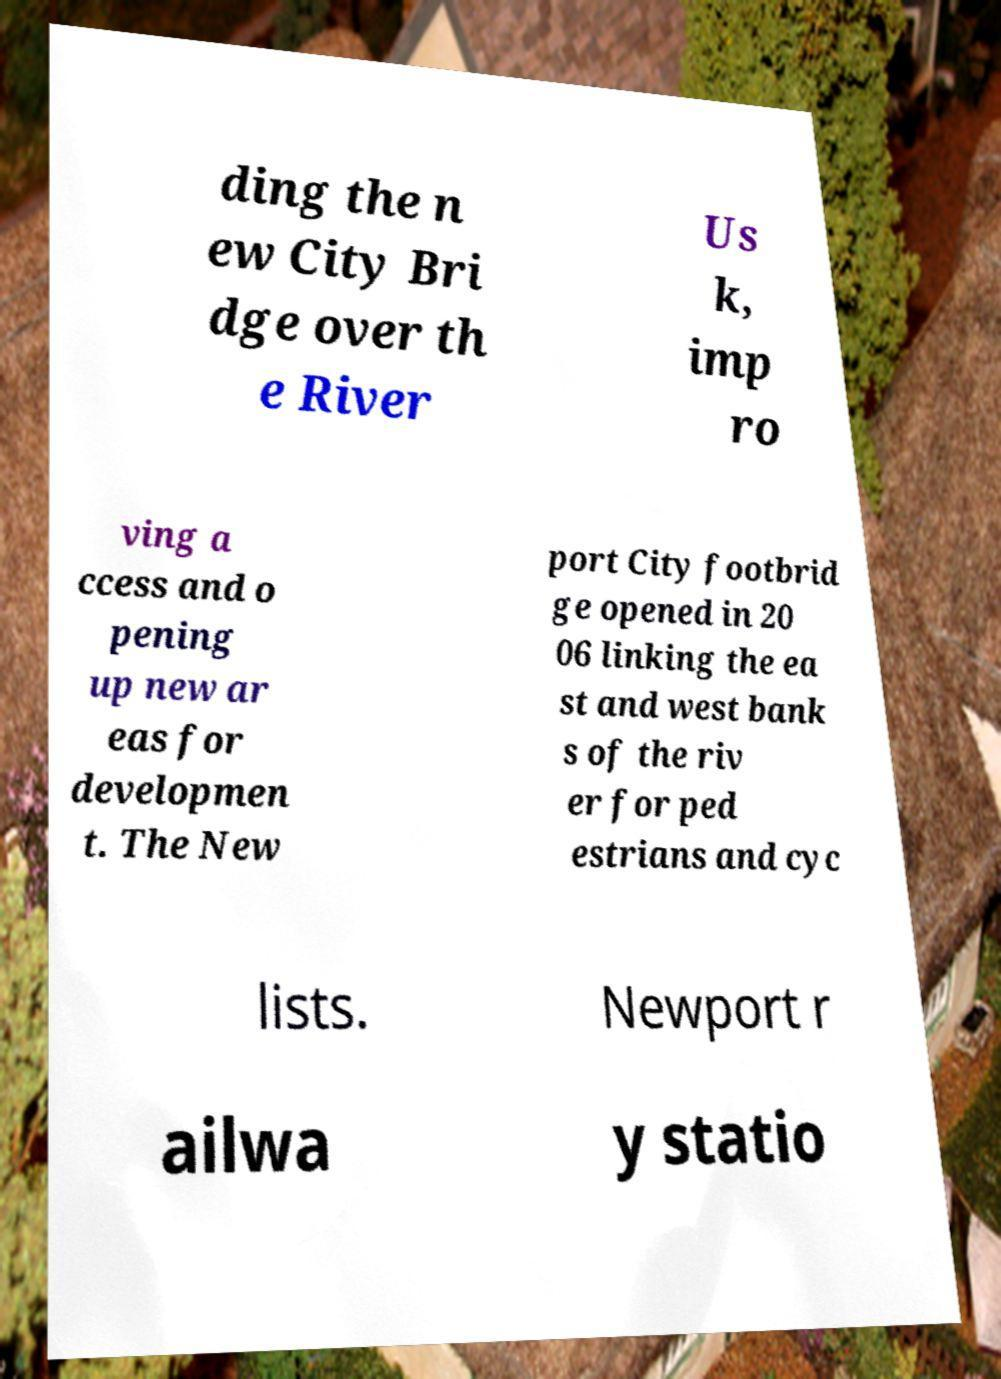Please read and relay the text visible in this image. What does it say? ding the n ew City Bri dge over th e River Us k, imp ro ving a ccess and o pening up new ar eas for developmen t. The New port City footbrid ge opened in 20 06 linking the ea st and west bank s of the riv er for ped estrians and cyc lists. Newport r ailwa y statio 